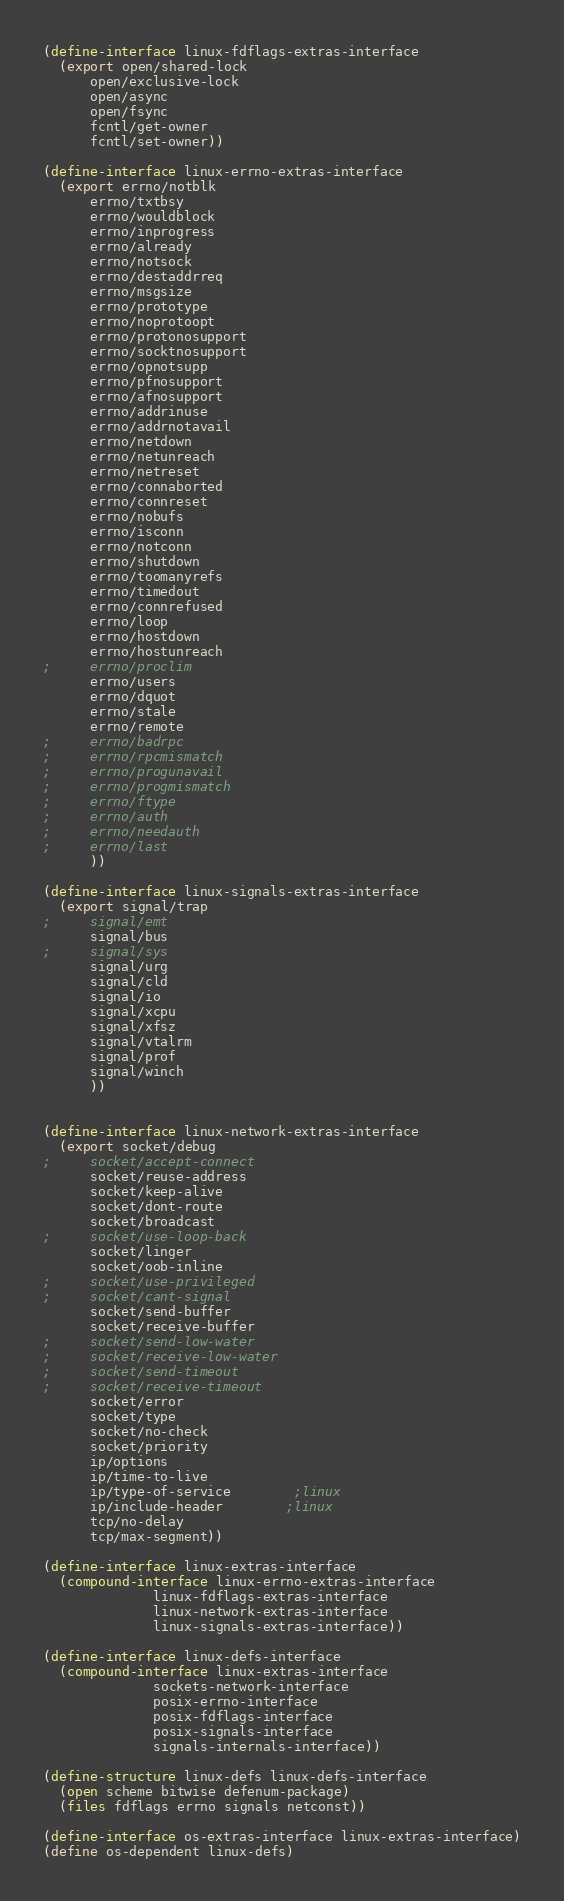<code> <loc_0><loc_0><loc_500><loc_500><_Scheme_>(define-interface linux-fdflags-extras-interface
  (export open/shared-lock
	  open/exclusive-lock
	  open/async
	  open/fsync
	  fcntl/get-owner
	  fcntl/set-owner))

(define-interface linux-errno-extras-interface
  (export errno/notblk	  
	  errno/txtbsy
	  errno/wouldblock
	  errno/inprogress
	  errno/already
	  errno/notsock
	  errno/destaddrreq
	  errno/msgsize
	  errno/prototype
	  errno/noprotoopt
	  errno/protonosupport
	  errno/socktnosupport
	  errno/opnotsupp
	  errno/pfnosupport
	  errno/afnosupport
	  errno/addrinuse
	  errno/addrnotavail
	  errno/netdown
	  errno/netunreach
	  errno/netreset
	  errno/connaborted
	  errno/connreset
	  errno/nobufs
	  errno/isconn
	  errno/notconn
	  errno/shutdown
	  errno/toomanyrefs
	  errno/timedout
	  errno/connrefused
	  errno/loop
	  errno/hostdown
	  errno/hostunreach
;	  errno/proclim
	  errno/users
	  errno/dquot
	  errno/stale
	  errno/remote
;	  errno/badrpc
;	  errno/rpcmismatch
;	  errno/progunavail
;	  errno/progmismatch
;	  errno/ftype 
;	  errno/auth
;	  errno/needauth
;	  errno/last
	  ))

(define-interface linux-signals-extras-interface
  (export signal/trap
;	  signal/emt
	  signal/bus
;	  signal/sys
	  signal/urg
	  signal/cld
	  signal/io
	  signal/xcpu
	  signal/xfsz
	  signal/vtalrm
	  signal/prof
	  signal/winch
	  ))


(define-interface linux-network-extras-interface
  (export socket/debug
;	  socket/accept-connect
	  socket/reuse-address
	  socket/keep-alive
	  socket/dont-route
	  socket/broadcast
;	  socket/use-loop-back
	  socket/linger
	  socket/oob-inline
;	  socket/use-privileged
;	  socket/cant-signal
	  socket/send-buffer
	  socket/receive-buffer
;	  socket/send-low-water
;	  socket/receive-low-water
;	  socket/send-timeout
;	  socket/receive-timeout
	  socket/error
	  socket/type
	  socket/no-check
	  socket/priority
	  ip/options
	  ip/time-to-live
	  ip/type-of-service		;linux
	  ip/include-header		;linux
	  tcp/no-delay
	  tcp/max-segment))

(define-interface linux-extras-interface
  (compound-interface linux-errno-extras-interface
		      linux-fdflags-extras-interface
		      linux-network-extras-interface
		      linux-signals-extras-interface))

(define-interface linux-defs-interface
  (compound-interface linux-extras-interface
		      sockets-network-interface
		      posix-errno-interface
		      posix-fdflags-interface
		      posix-signals-interface
		      signals-internals-interface))

(define-structure linux-defs linux-defs-interface
  (open scheme bitwise defenum-package)
  (files fdflags errno signals netconst))

(define-interface os-extras-interface linux-extras-interface)
(define os-dependent linux-defs)
</code> 